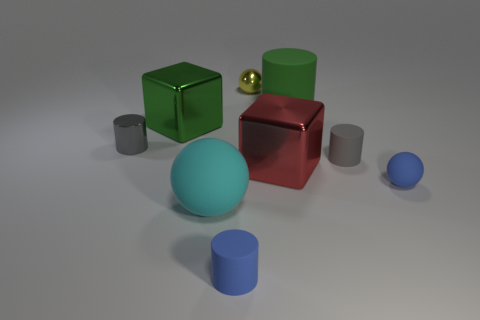There is a ball that is the same size as the red thing; what material is it?
Make the answer very short. Rubber. Do the cyan sphere and the tiny yellow object have the same material?
Keep it short and to the point. No. What number of other things are the same color as the big rubber cylinder?
Provide a short and direct response. 1. What material is the big green cube?
Your answer should be very brief. Metal. Are any tiny yellow matte cubes visible?
Make the answer very short. No. Are there an equal number of red blocks behind the small gray matte object and large cyan matte balls?
Give a very brief answer. No. Is there anything else that is made of the same material as the tiny yellow sphere?
Provide a short and direct response. Yes. What number of small objects are either purple metallic balls or blocks?
Keep it short and to the point. 0. The large metallic thing that is the same color as the large cylinder is what shape?
Make the answer very short. Cube. Does the small blue object that is on the right side of the tiny metal ball have the same material as the small yellow object?
Your response must be concise. No. 